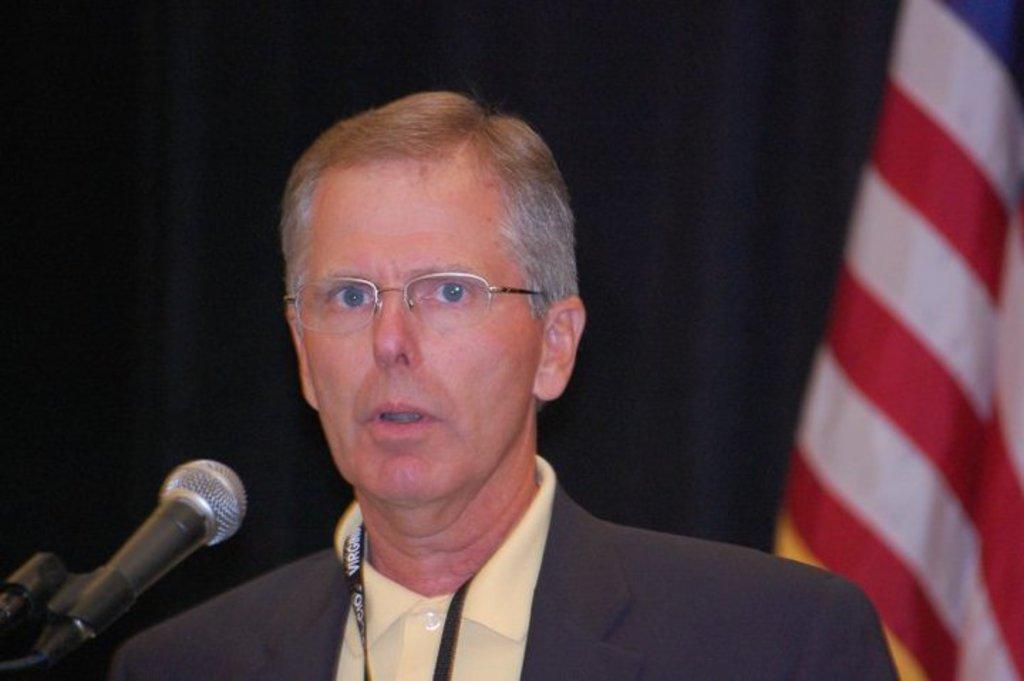Please provide a concise description of this image. In the center of the image, we can see a man wearing an id card and glasses and there is a mic. In the background, there is a curtain and there is a flag. 